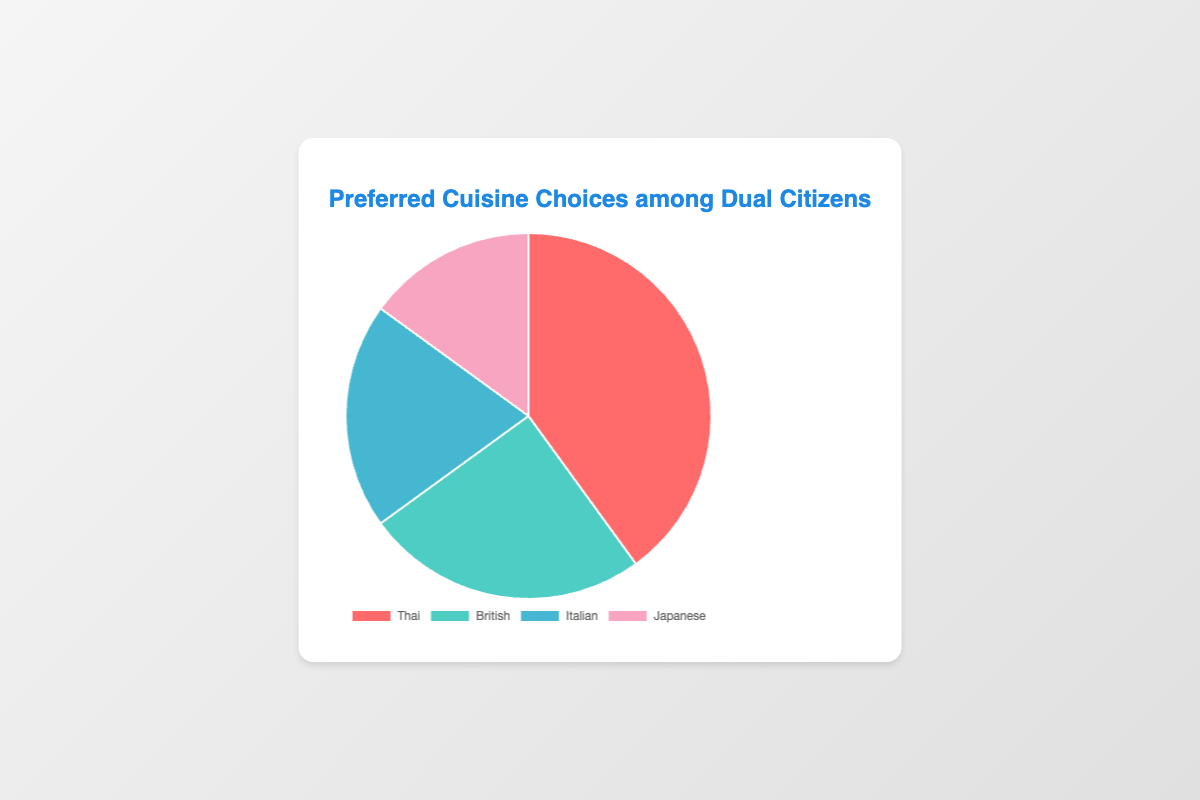What is the most preferred cuisine among dual citizens? The most preferred cuisine is the one with the highest percentage. According to the data, Thai cuisine has the highest percentage at 40%.
Answer: Thai What is the combined preference percentage for Italian and Japanese cuisines? To find the combined preference percentage, add the percentages for Italian and Japanese cuisines. Italian is 20% and Japanese is 15%, so 20% + 15% = 35%.
Answer: 35% Which cuisine shows a higher preference percentage, British or Japanese? Compare the percentage values for British and Japanese cuisines. British cuisine has a preference of 25%, while Japanese cuisine has a preference of 15%. Therefore, British cuisine shows a higher preference.
Answer: British How much larger is the preference for Thai cuisine compared to Italian cuisine? Subtract the percentage of Italian cuisine from the percentage of Thai cuisine. The preference for Thai cuisine is 40% and for Italian cuisine is 20%, so 40% - 20% = 20%.
Answer: 20% What are the colors used to represent Italian and Japanese cuisines on the pie chart? The colors can be identified by their description. Italian cuisine is represented by a different blue shade while Japanese cuisine is represented by a light pink shade.
Answer: Blue for Italian, Pink for Japanese What is the difference between the most and least preferred cuisines? Identify the most and least preferred cuisines and subtract their percentages. Thai cuisine is the most preferred at 40% and Japanese is the least preferred at 15%, so 40% - 15% = 25%.
Answer: 25% Which two cuisines have a combined preference percentage equal to the preference percentage of Thai cuisine? To match Thai cuisine's 40%, add the percentages of two other cuisines. British and Italian together make 25% + 20% = 45%, which is closest but exceeds by 5%. Japanese and Italian make 15% + 20% = 35%, which is short by 5%. No exact matches can be formed.
Answer: None What is the least preferred cuisine among dual citizens? Identify the one with the smallest percentage. According to the data, Japanese cuisine has the lowest percentage at 15%.
Answer: Japanese How much more popular is British cuisine compared to Japanese cuisine? Subtract the percentage of Japanese cuisine from the percentage of British cuisine. The preference for British cuisine is 25% and for Japanese cuisine is 15%, so 25% - 15% = 10%.
Answer: 10% 